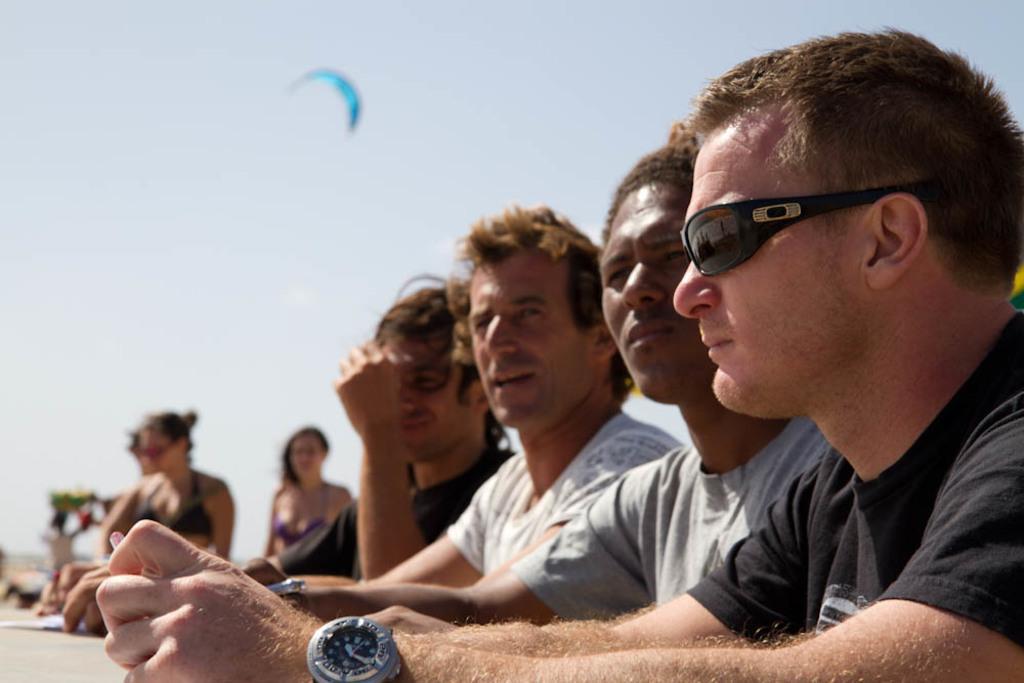Please provide a concise description of this image. In the picture I can see four men. They are wearing a T-shirt and looks like one of them is speaking. I can see two women on the left side. There are clouds in the sky. 